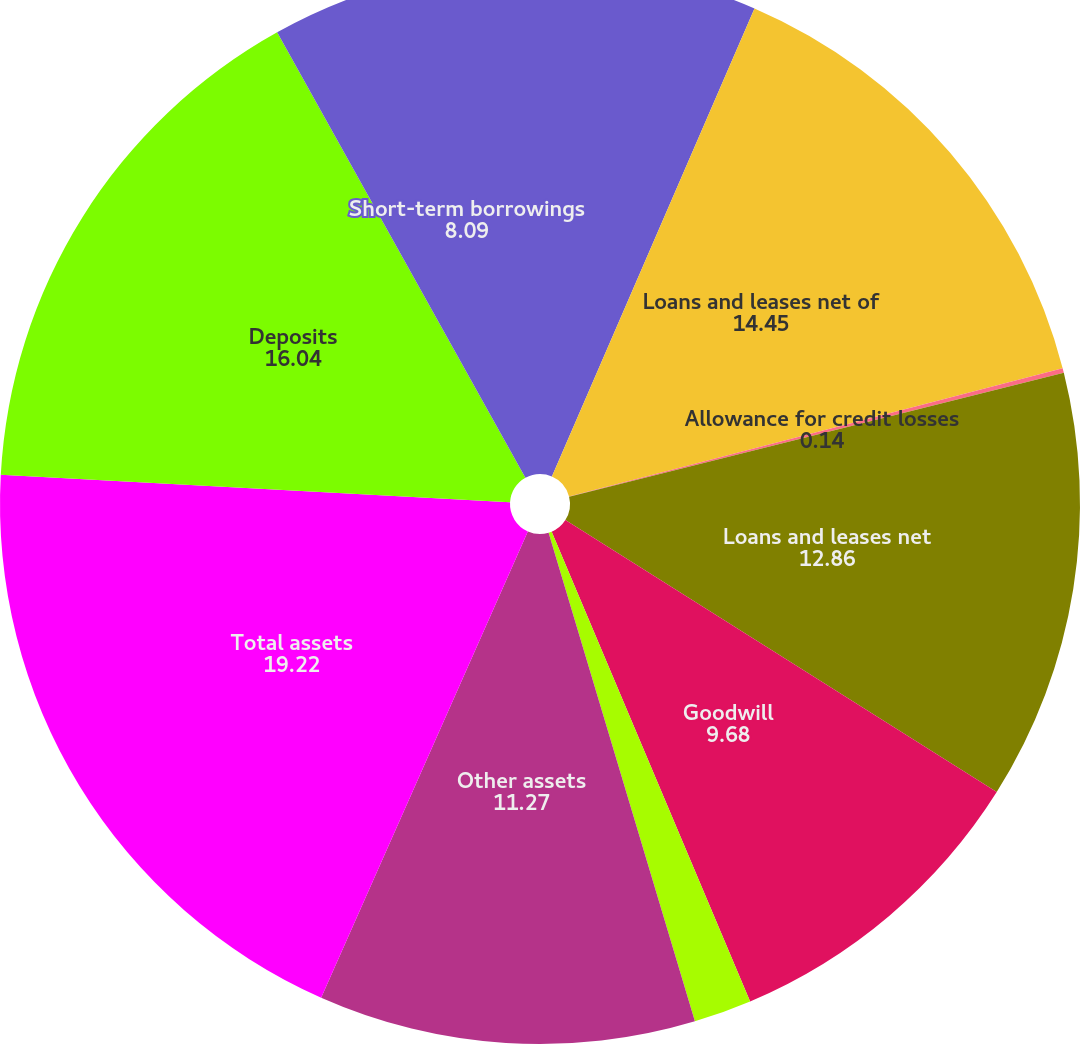Convert chart to OTSL. <chart><loc_0><loc_0><loc_500><loc_500><pie_chart><fcel>Investment securities<fcel>Loans and leases net of<fcel>Allowance for credit losses<fcel>Loans and leases net<fcel>Goodwill<fcel>Core deposit and other<fcel>Other assets<fcel>Total assets<fcel>Deposits<fcel>Short-term borrowings<nl><fcel>6.5%<fcel>14.45%<fcel>0.14%<fcel>12.86%<fcel>9.68%<fcel>1.73%<fcel>11.27%<fcel>19.22%<fcel>16.04%<fcel>8.09%<nl></chart> 